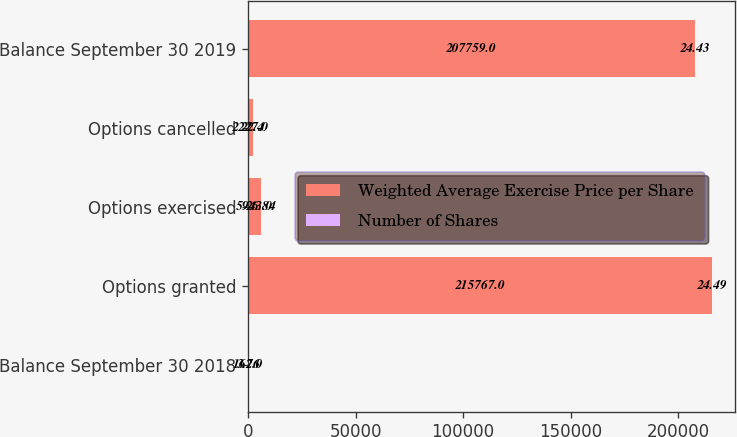Convert chart to OTSL. <chart><loc_0><loc_0><loc_500><loc_500><stacked_bar_chart><ecel><fcel>Balance September 30 2018<fcel>Options granted<fcel>Options exercised<fcel>Options cancelled<fcel>Balance September 30 2019<nl><fcel>Weighted Average Exercise Price per Share<fcel>162<fcel>215767<fcel>5943<fcel>2227<fcel>207759<nl><fcel>Number of Shares<fcel>3.76<fcel>24.49<fcel>26.84<fcel>22.4<fcel>24.43<nl></chart> 